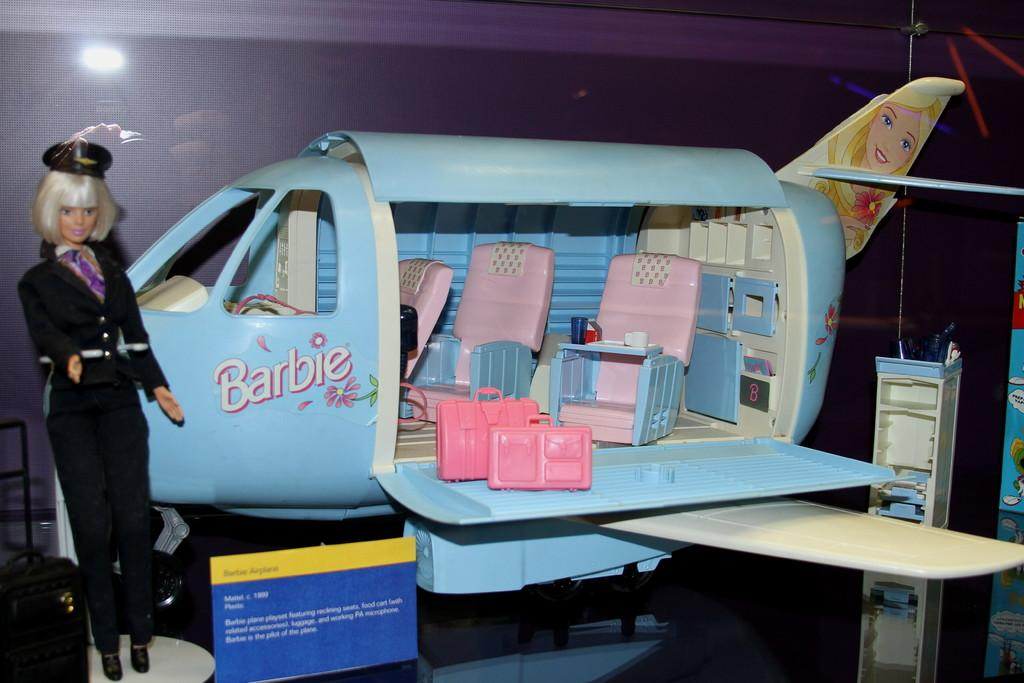What type of toy is on the floor in the image? There is an airplane toy on the floor. What kind of furniture is visible in the image? There are plastic chairs in the image. Where is the baby doll located in the image? The baby doll is on the left side of the image. Can you see a trail of footprints leading to the baby doll in the image? There is no trail of footprints visible in the image. Is the baby doll's dad present in the image? There is no indication of the baby doll's dad in the image. 